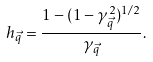<formula> <loc_0><loc_0><loc_500><loc_500>h _ { \vec { q } } = \frac { 1 - ( 1 - \gamma _ { \vec { q } } ^ { 2 } ) ^ { 1 / 2 } } { \gamma _ { \vec { q } } } .</formula> 